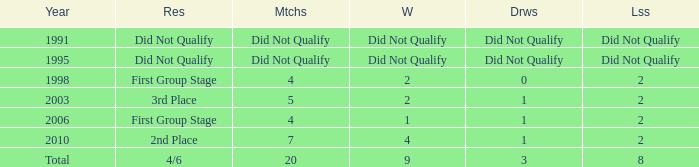What were the matches where the teams finished in the first group stage, in 1998? 4.0. 